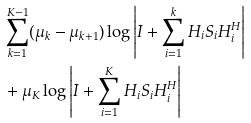Convert formula to latex. <formula><loc_0><loc_0><loc_500><loc_500>& \sum _ { k = 1 } ^ { K - 1 } ( \mu _ { k } - \mu _ { k + 1 } ) \log \left | { I } + \sum _ { i = 1 } ^ { k } { H } _ { i } { S } _ { i } { H } _ { i } ^ { H } \right | \\ & + \mu _ { K } \log \left | { I } + \sum _ { i = 1 } ^ { K } { H } _ { i } { S } _ { i } { H } _ { i } ^ { H } \right |</formula> 